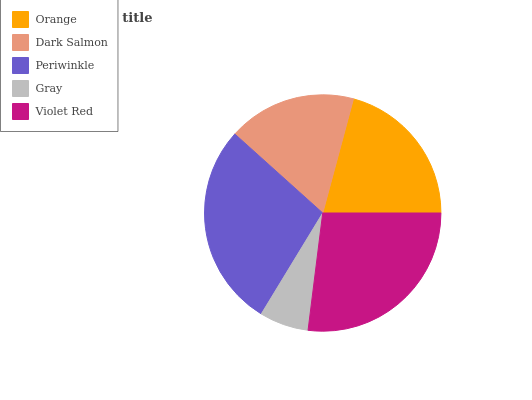Is Gray the minimum?
Answer yes or no. Yes. Is Periwinkle the maximum?
Answer yes or no. Yes. Is Dark Salmon the minimum?
Answer yes or no. No. Is Dark Salmon the maximum?
Answer yes or no. No. Is Orange greater than Dark Salmon?
Answer yes or no. Yes. Is Dark Salmon less than Orange?
Answer yes or no. Yes. Is Dark Salmon greater than Orange?
Answer yes or no. No. Is Orange less than Dark Salmon?
Answer yes or no. No. Is Orange the high median?
Answer yes or no. Yes. Is Orange the low median?
Answer yes or no. Yes. Is Violet Red the high median?
Answer yes or no. No. Is Violet Red the low median?
Answer yes or no. No. 